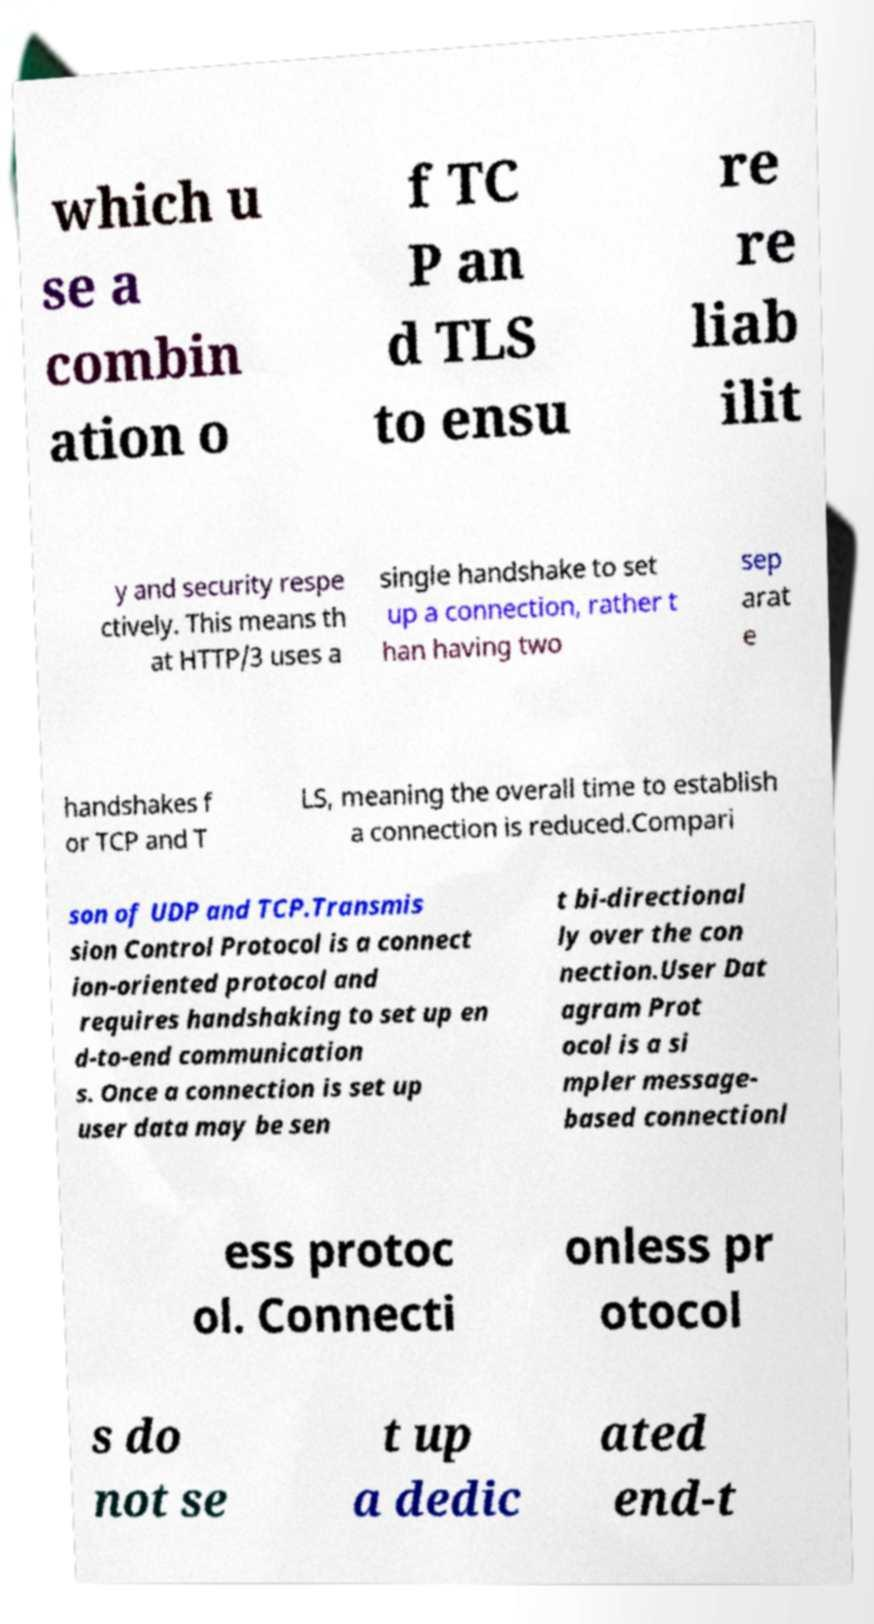Please identify and transcribe the text found in this image. which u se a combin ation o f TC P an d TLS to ensu re re liab ilit y and security respe ctively. This means th at HTTP/3 uses a single handshake to set up a connection, rather t han having two sep arat e handshakes f or TCP and T LS, meaning the overall time to establish a connection is reduced.Compari son of UDP and TCP.Transmis sion Control Protocol is a connect ion-oriented protocol and requires handshaking to set up en d-to-end communication s. Once a connection is set up user data may be sen t bi-directional ly over the con nection.User Dat agram Prot ocol is a si mpler message- based connectionl ess protoc ol. Connecti onless pr otocol s do not se t up a dedic ated end-t 